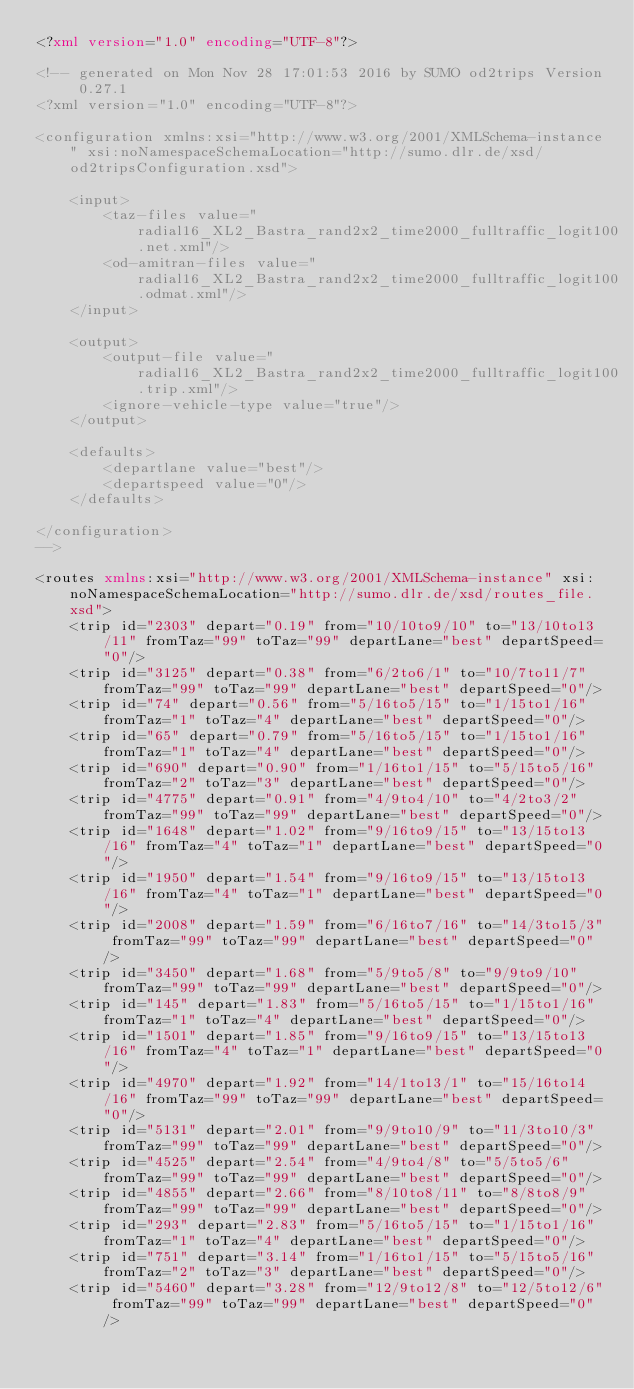<code> <loc_0><loc_0><loc_500><loc_500><_XML_><?xml version="1.0" encoding="UTF-8"?>

<!-- generated on Mon Nov 28 17:01:53 2016 by SUMO od2trips Version 0.27.1
<?xml version="1.0" encoding="UTF-8"?>

<configuration xmlns:xsi="http://www.w3.org/2001/XMLSchema-instance" xsi:noNamespaceSchemaLocation="http://sumo.dlr.de/xsd/od2tripsConfiguration.xsd">

    <input>
        <taz-files value="radial16_XL2_Bastra_rand2x2_time2000_fulltraffic_logit100.net.xml"/>
        <od-amitran-files value="radial16_XL2_Bastra_rand2x2_time2000_fulltraffic_logit100.odmat.xml"/>
    </input>

    <output>
        <output-file value="radial16_XL2_Bastra_rand2x2_time2000_fulltraffic_logit100.trip.xml"/>
        <ignore-vehicle-type value="true"/>
    </output>

    <defaults>
        <departlane value="best"/>
        <departspeed value="0"/>
    </defaults>

</configuration>
-->

<routes xmlns:xsi="http://www.w3.org/2001/XMLSchema-instance" xsi:noNamespaceSchemaLocation="http://sumo.dlr.de/xsd/routes_file.xsd">
    <trip id="2303" depart="0.19" from="10/10to9/10" to="13/10to13/11" fromTaz="99" toTaz="99" departLane="best" departSpeed="0"/>
    <trip id="3125" depart="0.38" from="6/2to6/1" to="10/7to11/7" fromTaz="99" toTaz="99" departLane="best" departSpeed="0"/>
    <trip id="74" depart="0.56" from="5/16to5/15" to="1/15to1/16" fromTaz="1" toTaz="4" departLane="best" departSpeed="0"/>
    <trip id="65" depart="0.79" from="5/16to5/15" to="1/15to1/16" fromTaz="1" toTaz="4" departLane="best" departSpeed="0"/>
    <trip id="690" depart="0.90" from="1/16to1/15" to="5/15to5/16" fromTaz="2" toTaz="3" departLane="best" departSpeed="0"/>
    <trip id="4775" depart="0.91" from="4/9to4/10" to="4/2to3/2" fromTaz="99" toTaz="99" departLane="best" departSpeed="0"/>
    <trip id="1648" depart="1.02" from="9/16to9/15" to="13/15to13/16" fromTaz="4" toTaz="1" departLane="best" departSpeed="0"/>
    <trip id="1950" depart="1.54" from="9/16to9/15" to="13/15to13/16" fromTaz="4" toTaz="1" departLane="best" departSpeed="0"/>
    <trip id="2008" depart="1.59" from="6/16to7/16" to="14/3to15/3" fromTaz="99" toTaz="99" departLane="best" departSpeed="0"/>
    <trip id="3450" depart="1.68" from="5/9to5/8" to="9/9to9/10" fromTaz="99" toTaz="99" departLane="best" departSpeed="0"/>
    <trip id="145" depart="1.83" from="5/16to5/15" to="1/15to1/16" fromTaz="1" toTaz="4" departLane="best" departSpeed="0"/>
    <trip id="1501" depart="1.85" from="9/16to9/15" to="13/15to13/16" fromTaz="4" toTaz="1" departLane="best" departSpeed="0"/>
    <trip id="4970" depart="1.92" from="14/1to13/1" to="15/16to14/16" fromTaz="99" toTaz="99" departLane="best" departSpeed="0"/>
    <trip id="5131" depart="2.01" from="9/9to10/9" to="11/3to10/3" fromTaz="99" toTaz="99" departLane="best" departSpeed="0"/>
    <trip id="4525" depart="2.54" from="4/9to4/8" to="5/5to5/6" fromTaz="99" toTaz="99" departLane="best" departSpeed="0"/>
    <trip id="4855" depart="2.66" from="8/10to8/11" to="8/8to8/9" fromTaz="99" toTaz="99" departLane="best" departSpeed="0"/>
    <trip id="293" depart="2.83" from="5/16to5/15" to="1/15to1/16" fromTaz="1" toTaz="4" departLane="best" departSpeed="0"/>
    <trip id="751" depart="3.14" from="1/16to1/15" to="5/15to5/16" fromTaz="2" toTaz="3" departLane="best" departSpeed="0"/>
    <trip id="5460" depart="3.28" from="12/9to12/8" to="12/5to12/6" fromTaz="99" toTaz="99" departLane="best" departSpeed="0"/></code> 